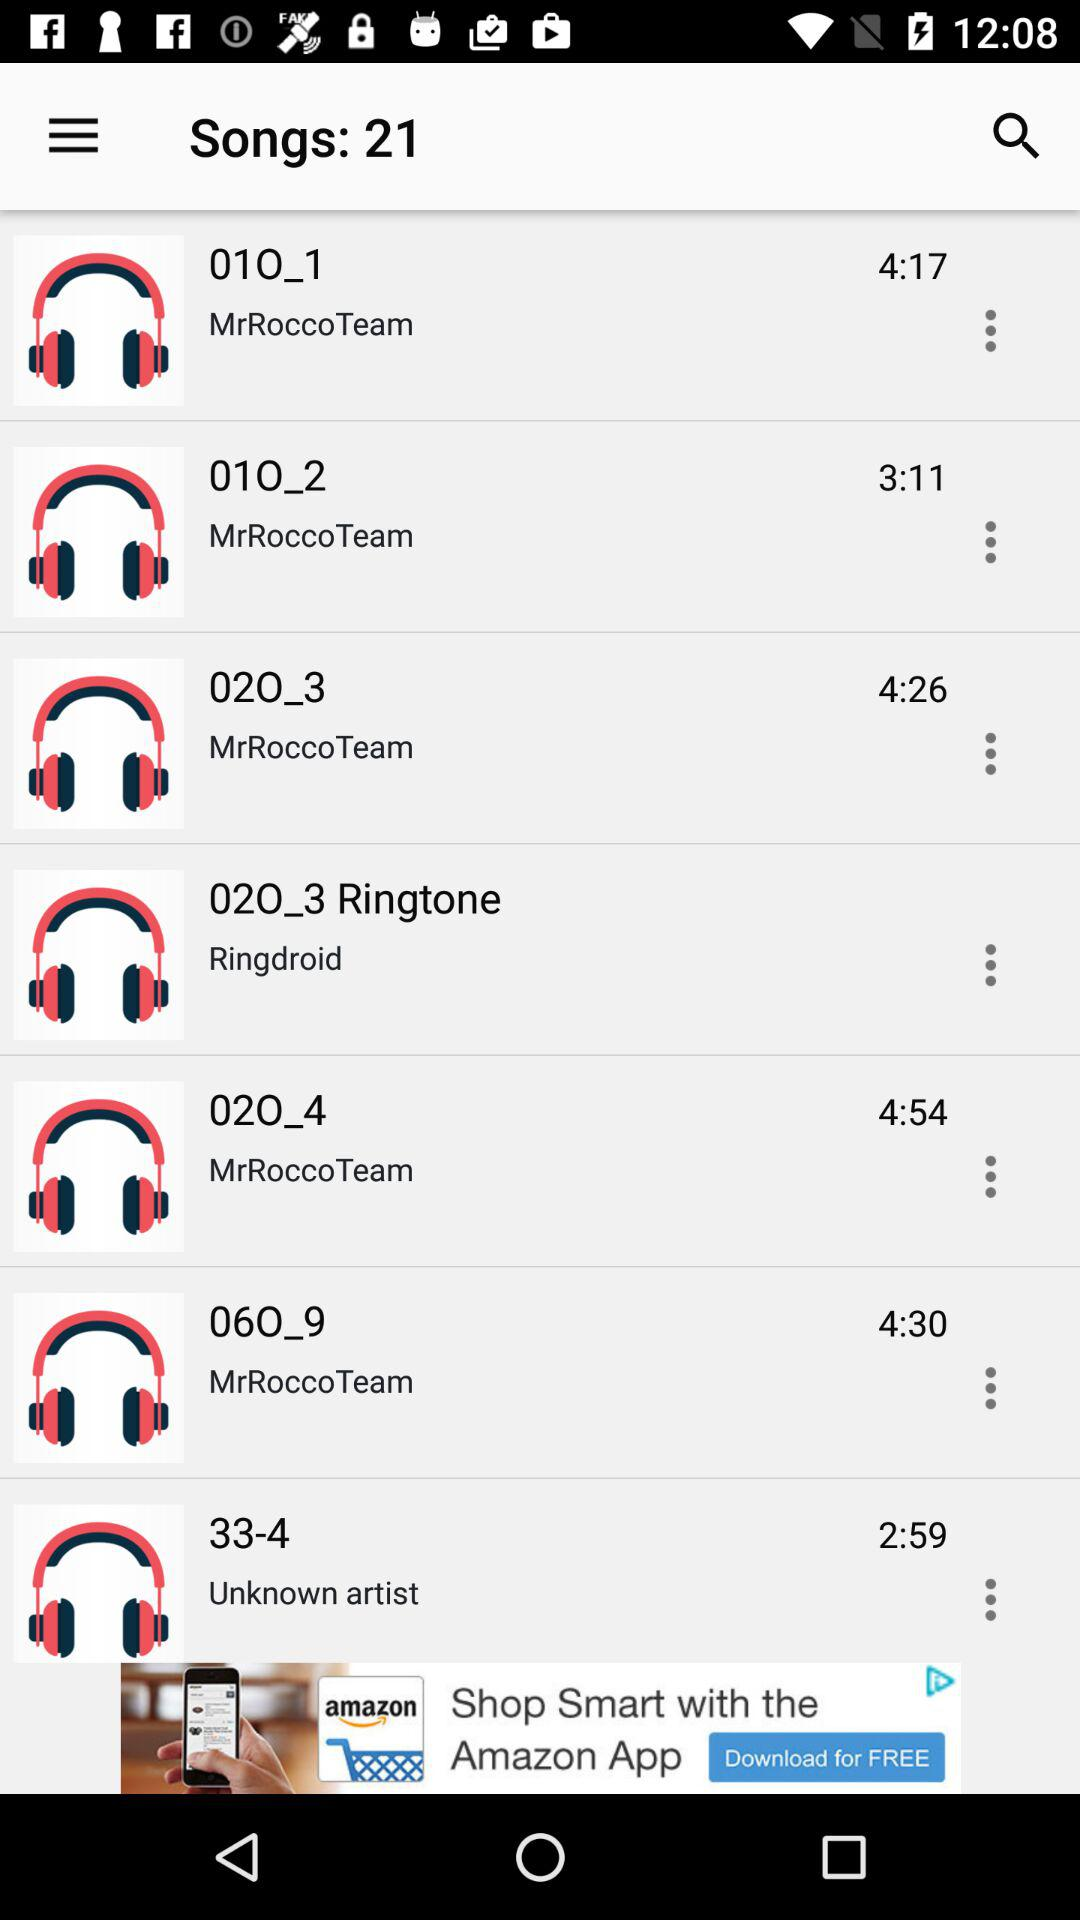What is the duration of "010_2"? The duration of "010_2" is 3:11. 